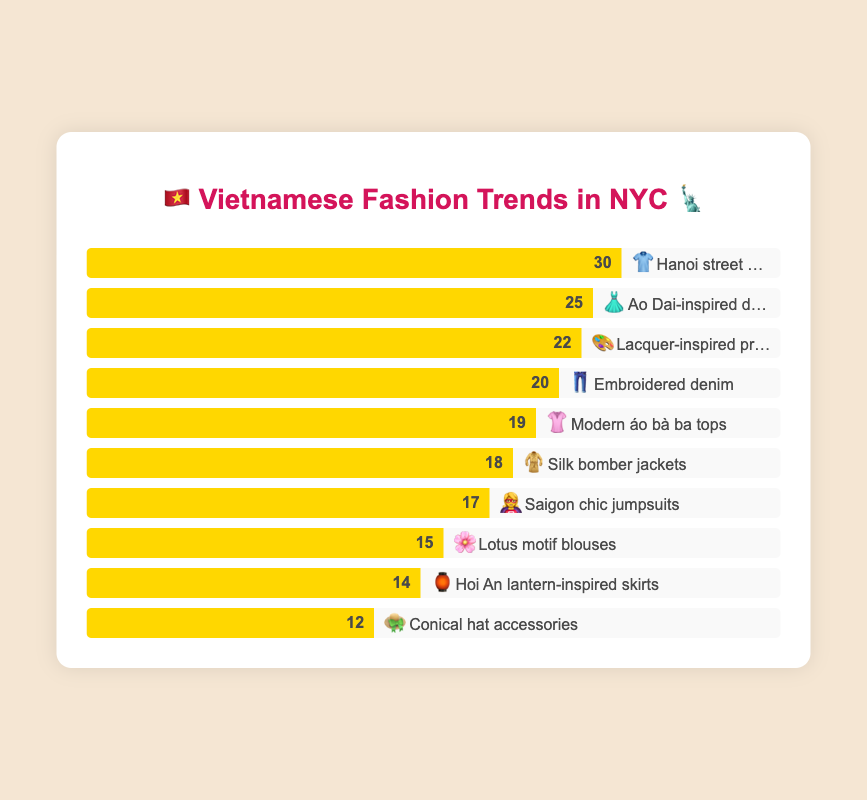What's the most popular Vietnamese fashion trend in NYC according to the chart? The "Hanoi street style tees" bar is the highest, indicating it is the most popular trend with a count of 30.
Answer: "Hanoi street style tees" Which Vietnamese fashion trend has the least popularity in NYC? Look for the shortest bar in the chart; the "Conical hat accessories" is the shortest, meaning it's the least popular with a count of 12.
Answer: "Conical hat accessories" How many more people prefer Ao Dai-inspired dresses than Lotus motif blouses? The count for Ao Dai-inspired dresses is 25, and for Lotus motif blouses, it's 15. Subtract the two values: 25 - 15 = 10.
Answer: 10 If you sum the popularity of Silk bomber jackets and Modern áo bà ba tops, what do you get? Silk bomber jackets have a value of 18, and Modern áo bà ba tops have a value of 19. Adding these together gives: 18 + 19 = 37.
Answer: 37 Which categories have a popularity between 15 and 20? Look at the bars with values between 15 and 20: "Lotus motif blouses" (15), "Saigon chic jumpsuits" (17), and "Modern áo bà ba tops" (19).
Answer: "Lotus motif blouses", "Saigon chic jumpsuits", "Modern áo bà ba tops" What is the total popularity value for trends that involve tops? "Modern áo bà ba tops" (19) and "Hanoi street style tees" (30). Adding these: 19 + 30 = 49.
Answer: 49 Compare the popularity of embroidered denim to lacquer-inspired prints. Which one is more popular? "Embroidered denim" has a value of 20, while "Lacquer-inspired prints" has a value of 22. The prints are more popular.
Answer: Lacquer-inspired prints If you average the popularity of Ao Dai-inspired dresses, Hanoi street style tees, and Lacquer-inspired prints, what do you get? Add the values: 25 (dresses) + 30 (tees) + 22 (prints) = 77. Divide by 3: 77 / 3 ≈ 25.67.
Answer: 25.67 What is the combined popularity of the least and the most popular trends? "Conical hat accessories" (12) and "Hanoi street style tees" (30) are the least and most popular. Adding them gives: 12 + 30 = 42.
Answer: 42 How does the popularity of Hoi An lantern-inspired skirts compare to Silk bomber jackets? "Hoi An lantern-inspired skirts" has a value of 14, and "Silk bomber jackets" has a value of 18. The jackets are more popular.
Answer: Silk bomber jackets 